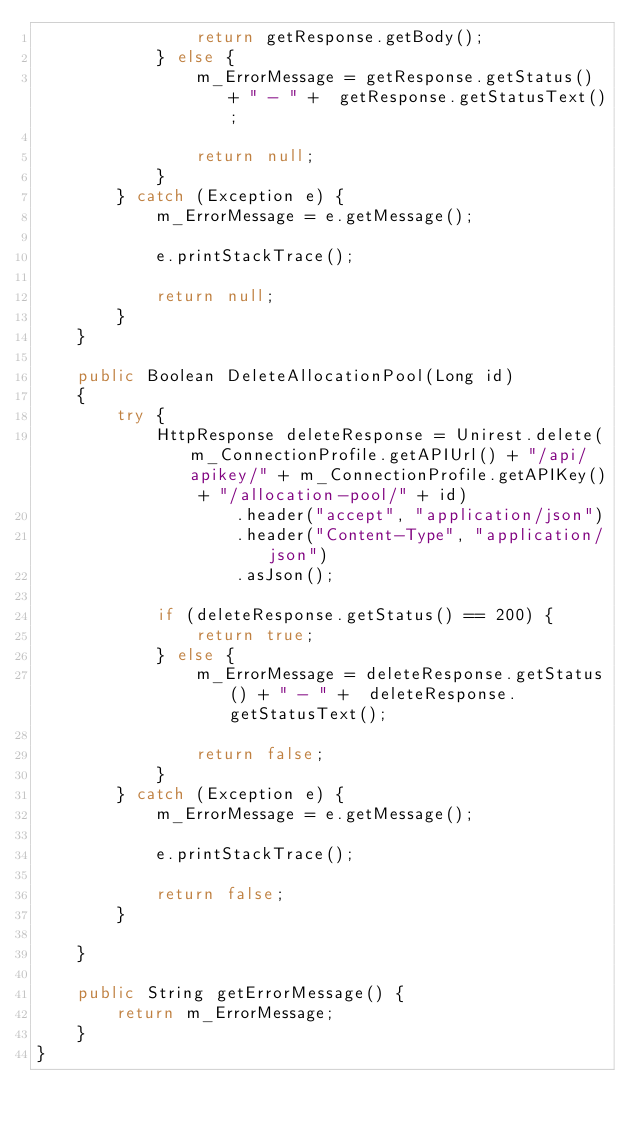Convert code to text. <code><loc_0><loc_0><loc_500><loc_500><_Java_>                return getResponse.getBody();
            } else {
                m_ErrorMessage = getResponse.getStatus() + " - " +  getResponse.getStatusText();

                return null;
            }
        } catch (Exception e) {
            m_ErrorMessage = e.getMessage();

            e.printStackTrace();

            return null;
        }
    }

    public Boolean DeleteAllocationPool(Long id)
    {
        try {
            HttpResponse deleteResponse = Unirest.delete(m_ConnectionProfile.getAPIUrl() + "/api/apikey/" + m_ConnectionProfile.getAPIKey() + "/allocation-pool/" + id)
                    .header("accept", "application/json")
                    .header("Content-Type", "application/json")
                    .asJson();

            if (deleteResponse.getStatus() == 200) {
                return true;
            } else {
                m_ErrorMessage = deleteResponse.getStatus() + " - " +  deleteResponse.getStatusText();

                return false;
            }
        } catch (Exception e) {
            m_ErrorMessage = e.getMessage();

            e.printStackTrace();

            return false;
        }

    }

    public String getErrorMessage() {
        return m_ErrorMessage;
    }
}
</code> 